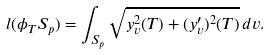<formula> <loc_0><loc_0><loc_500><loc_500>l ( \phi _ { T } S _ { p } ) = \int _ { S _ { p } } \sqrt { y _ { v } ^ { 2 } ( T ) + ( y _ { v } ^ { \prime } ) ^ { 2 } ( T ) } \, d v .</formula> 